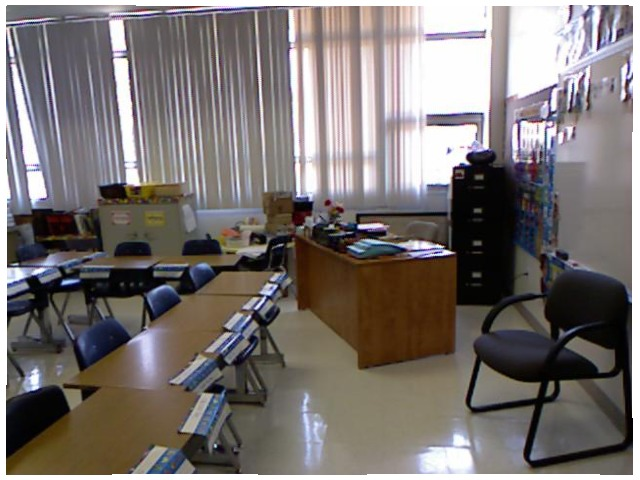<image>
Can you confirm if the chair is under the desk? No. The chair is not positioned under the desk. The vertical relationship between these objects is different. Where is the light in relation to the window? Is it in the window? Yes. The light is contained within or inside the window, showing a containment relationship. 